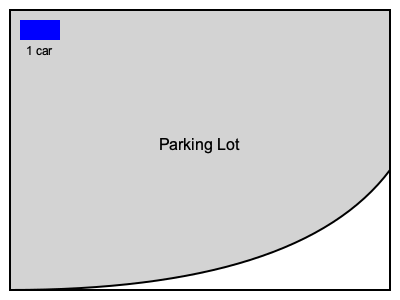Estimate the number of cars that can fit in this irregularly shaped parking lot. The blue rectangle represents one standard parking space. Round your answer to the nearest 5 cars. To estimate the number of cars that can fit in this irregularly shaped parking lot, we'll follow these steps:

1. Divide the parking lot into approximate rectangular sections:
   - Section A: Main rectangular area (about 9/10 of the width and 2/3 of the height)
   - Section B: Curved area (remaining 1/3 of the height)

2. Estimate the number of cars in Section A:
   - Width: Approximately 9 car lengths
   - Height: Approximately 6 car lengths
   - Area of Section A: $9 \times 6 = 54$ car spaces

3. Estimate the number of cars in Section B:
   - Curved area is roughly triangular
   - Base: Approximately 9 car lengths
   - Height: Approximately 3 car lengths
   - Area of Section B: $\frac{1}{2} \times 9 \times 3 = 13.5$ car spaces

4. Sum up the total number of car spaces:
   $54 + 13.5 = 67.5$ car spaces

5. Round to the nearest 5 cars:
   $67.5$ rounds to $70$ cars

Therefore, we estimate that approximately 70 cars can fit in this irregularly shaped parking lot.
Answer: 70 cars 